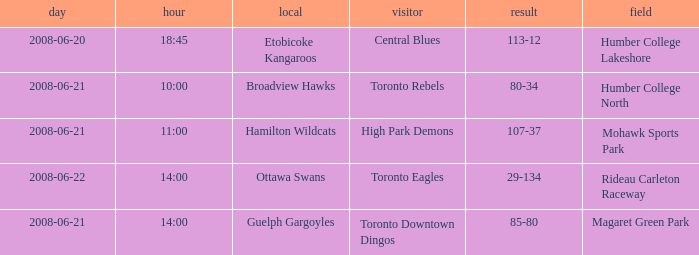What is the Away with a Ground that is humber college north? Toronto Rebels. 